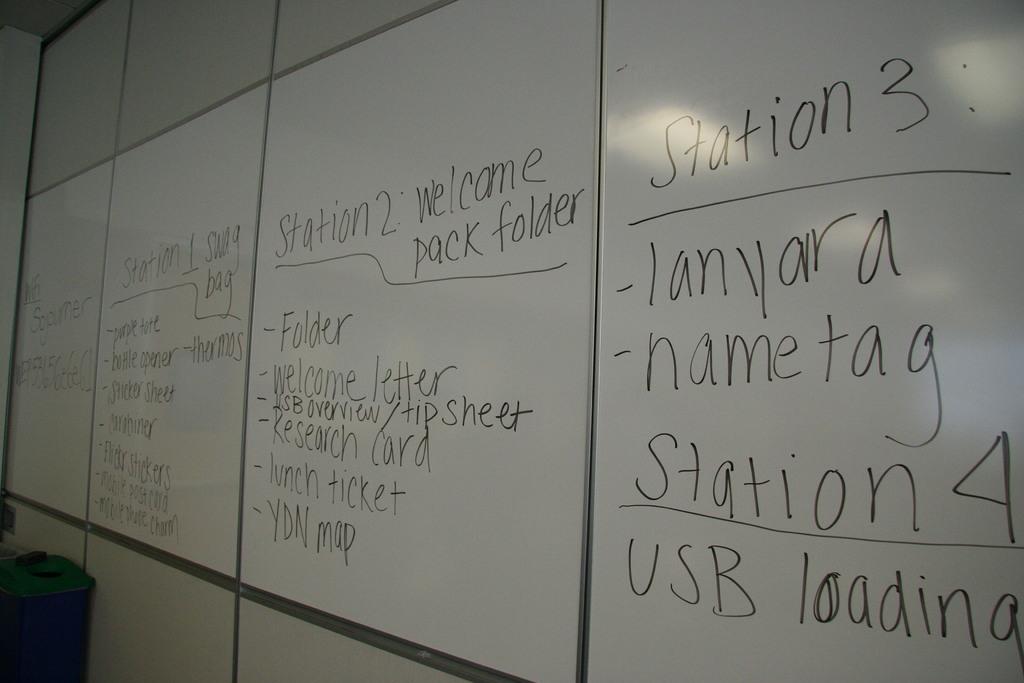What does station 4 has under it?
Ensure brevity in your answer.  Usb loading. What does station 3 have under it?
Provide a short and direct response. Lanyara nametag. 